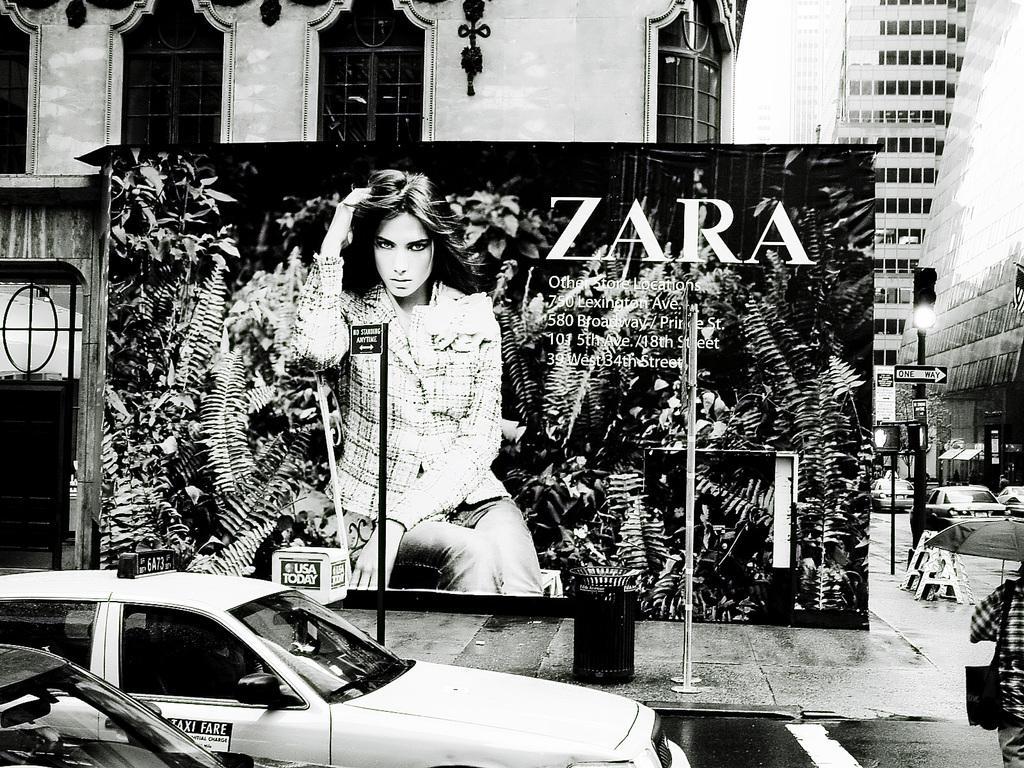Describe this image in one or two sentences. This is the picture of a place where we have some cars on the road and around there are some poles and buildings and a poster. 